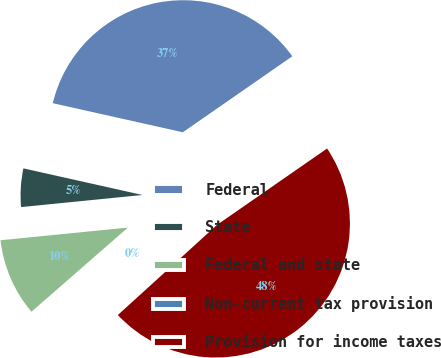Convert chart. <chart><loc_0><loc_0><loc_500><loc_500><pie_chart><fcel>Federal<fcel>State<fcel>Federal and state<fcel>Non-current tax provision<fcel>Provision for income taxes<nl><fcel>36.84%<fcel>5.08%<fcel>9.84%<fcel>0.32%<fcel>47.91%<nl></chart> 